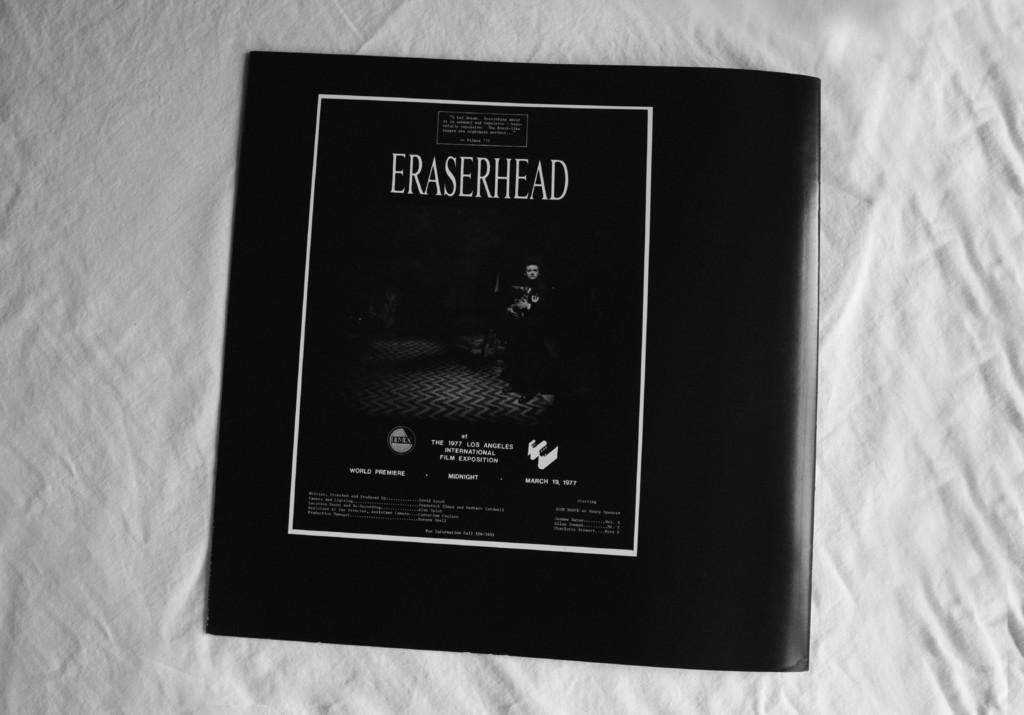Provide a one-sentence caption for the provided image. white fabric background with black eraserhead cd laying on it. 